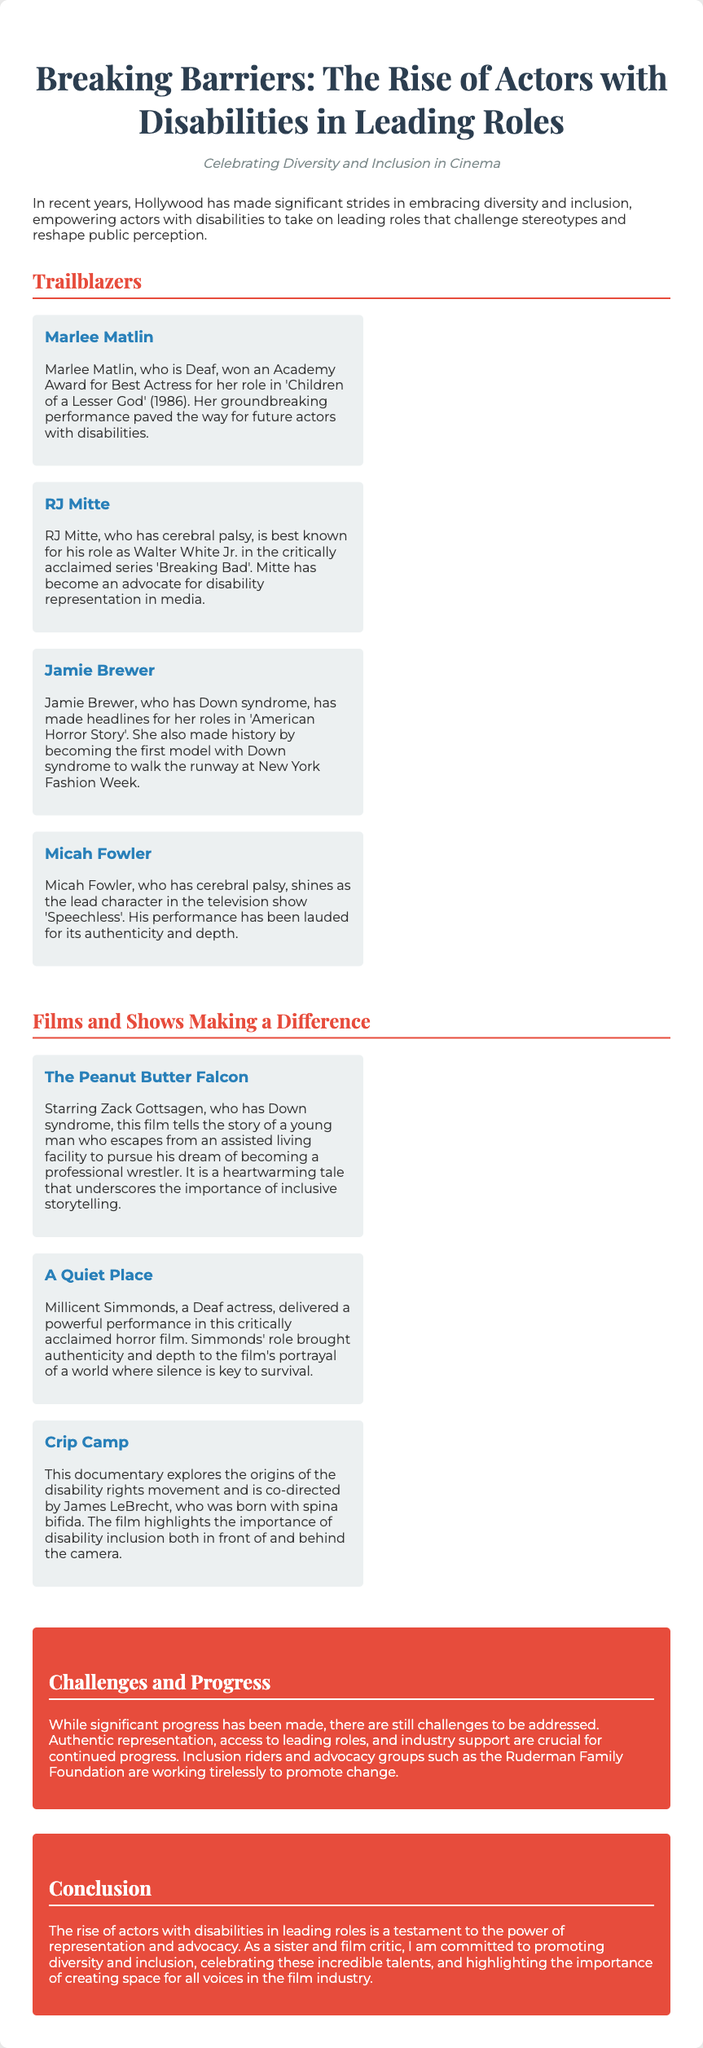What is the title of the poster? The title gives a clear indication of the main theme discussed in the document.
Answer: Breaking Barriers: The Rise of Actors with Disabilities in Leading Roles Who won an Academy Award for Best Actress for her role in 'Children of a Lesser God'? This question targets a specific individual mentioned in the trailblazers section.
Answer: Marlee Matlin Which actress, known for her role in 'Breaking Bad', has cerebral palsy? This requires connecting RJ Mitte with his notable role in a well-known show.
Answer: RJ Mitte What is the name of the documentary that explores the origins of the disability rights movement? This information is specifically found in the films section.
Answer: Crip Camp How many trailblazers are listed in the document? This requires counting the individuals specifically mentioned in the trailblazers section.
Answer: Four What is a challenge still faced by actors with disabilities in Hollywood? This question connects to the challenges described in the challenges section of the document.
Answer: Authentic representation What significant role does Millicent Simmonds play in 'A Quiet Place'? This question clarifies the contribution of the actress in a specific film.
Answer: A Deaf actress Which organization is mentioned as working to promote change for disability representation? This identifies a specific advocacy group highlighted in the text.
Answer: Ruderman Family Foundation What type of storytelling does 'The Peanut Butter Falcon' emphasize? This question assesses understanding of the film’s underlying message discussed in the document.
Answer: Inclusive storytelling 